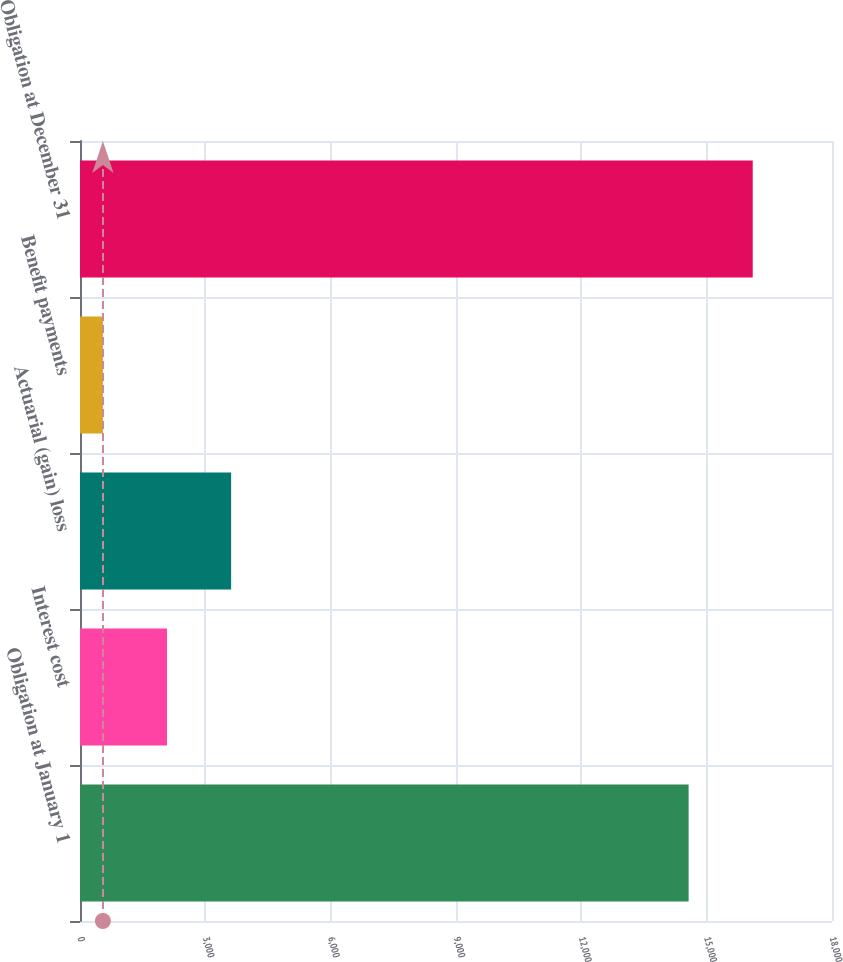Convert chart to OTSL. <chart><loc_0><loc_0><loc_500><loc_500><bar_chart><fcel>Obligation at January 1<fcel>Interest cost<fcel>Actuarial (gain) loss<fcel>Benefit payments<fcel>Obligation at December 31<nl><fcel>14568<fcel>2082.7<fcel>3617.4<fcel>548<fcel>16102.7<nl></chart> 